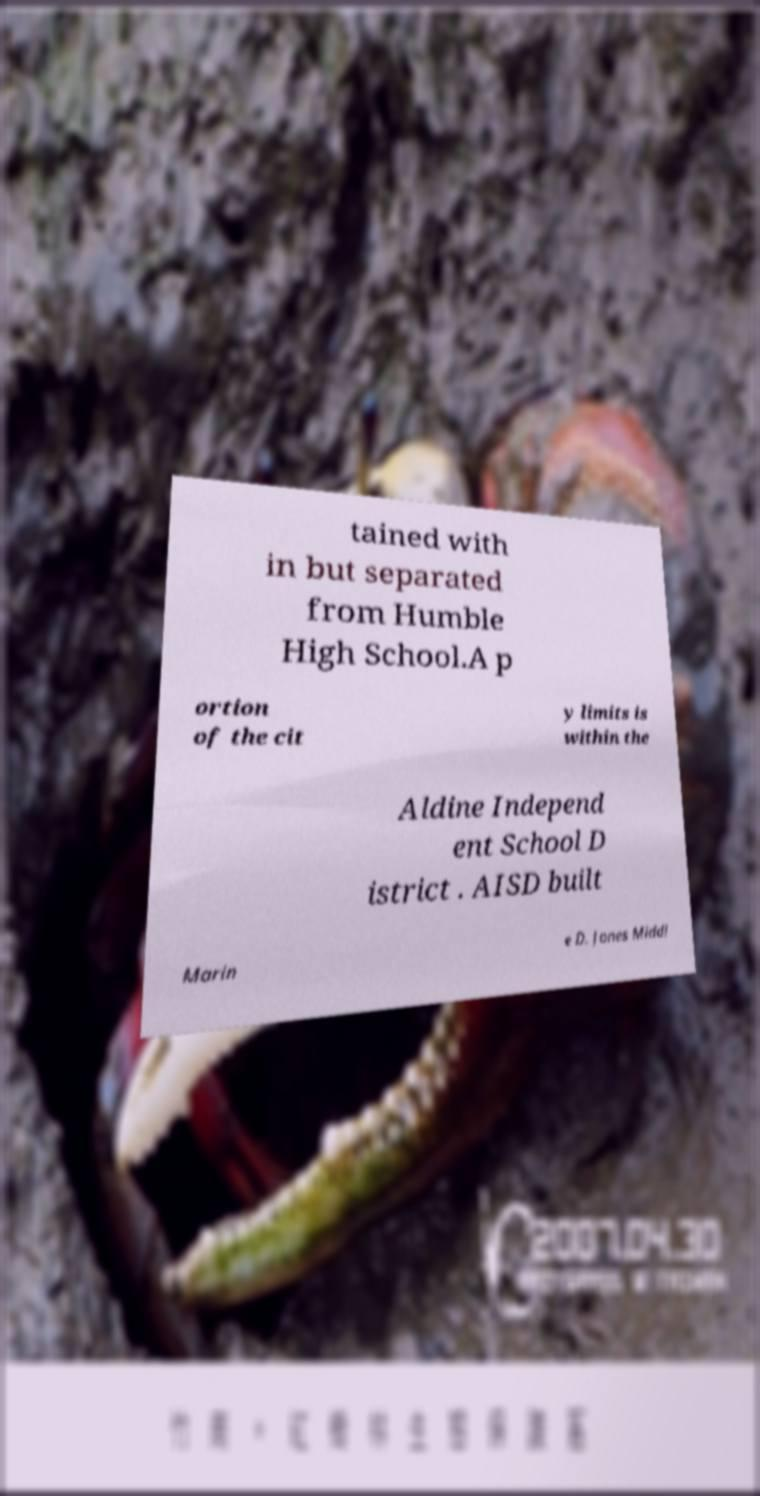I need the written content from this picture converted into text. Can you do that? tained with in but separated from Humble High School.A p ortion of the cit y limits is within the Aldine Independ ent School D istrict . AISD built Marin e D. Jones Middl 